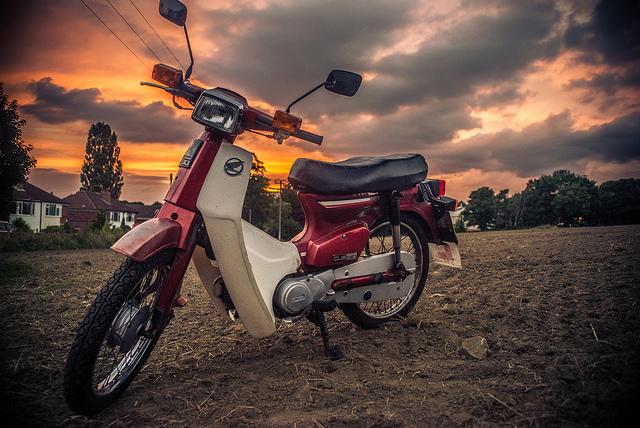What is the bike sitting on?
Keep it brief. Dirt. What color is the vehicle?
Short answer required. Red and white. Is it daytime?
Short answer required. Yes. Is this a Harley Davidson?
Quick response, please. No. 